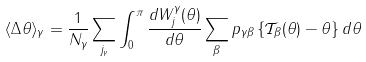<formula> <loc_0><loc_0><loc_500><loc_500>\langle \Delta \theta \rangle _ { \gamma } = \frac { 1 } { N _ { \gamma } } \sum _ { j _ { \gamma } } \int _ { 0 } ^ { \pi } \frac { d W _ { j } ^ { \gamma } ( \theta ) } { d \theta } \sum _ { \beta } p _ { \gamma \beta } \left \{ \mathcal { T } _ { \beta } ( \theta ) - \theta \right \} d \theta</formula> 